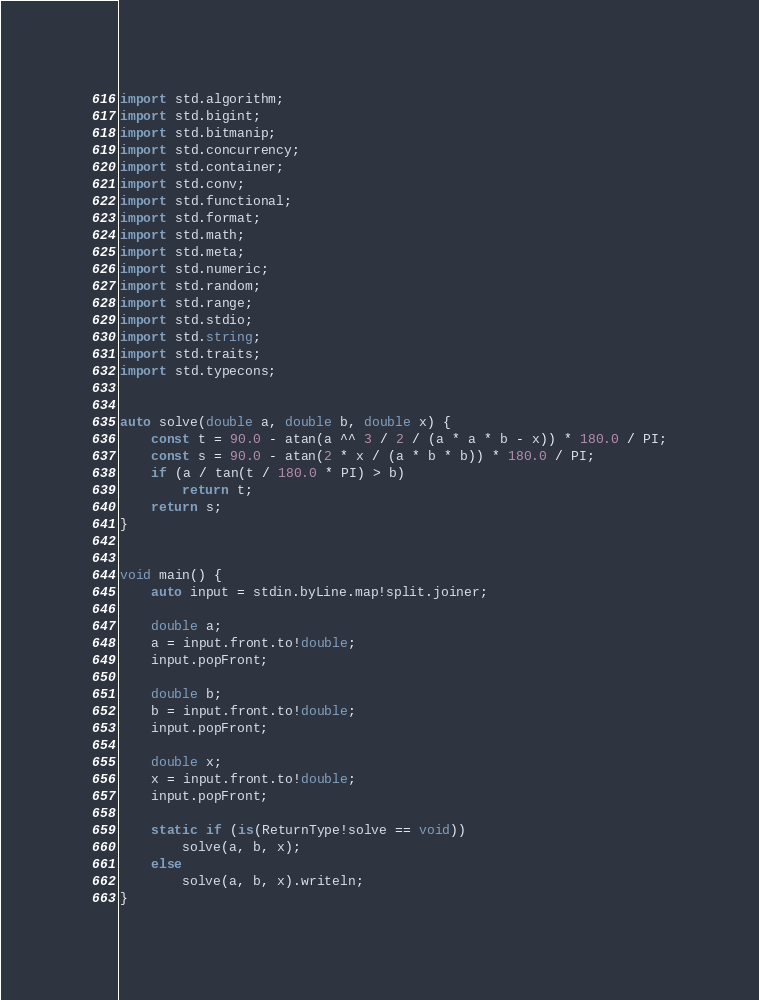<code> <loc_0><loc_0><loc_500><loc_500><_D_>import std.algorithm;
import std.bigint;
import std.bitmanip;
import std.concurrency;
import std.container;
import std.conv;
import std.functional;
import std.format;
import std.math;
import std.meta;
import std.numeric;
import std.random;
import std.range;
import std.stdio;
import std.string;
import std.traits;
import std.typecons;


auto solve(double a, double b, double x) {
    const t = 90.0 - atan(a ^^ 3 / 2 / (a * a * b - x)) * 180.0 / PI;
    const s = 90.0 - atan(2 * x / (a * b * b)) * 180.0 / PI;
    if (a / tan(t / 180.0 * PI) > b)
        return t;
    return s;
}


void main() {
    auto input = stdin.byLine.map!split.joiner;

    double a;
    a = input.front.to!double;
    input.popFront;

    double b;
    b = input.front.to!double;
    input.popFront;

    double x;
    x = input.front.to!double;
    input.popFront;

    static if (is(ReturnType!solve == void))
        solve(a, b, x);
    else
        solve(a, b, x).writeln;
}
</code> 